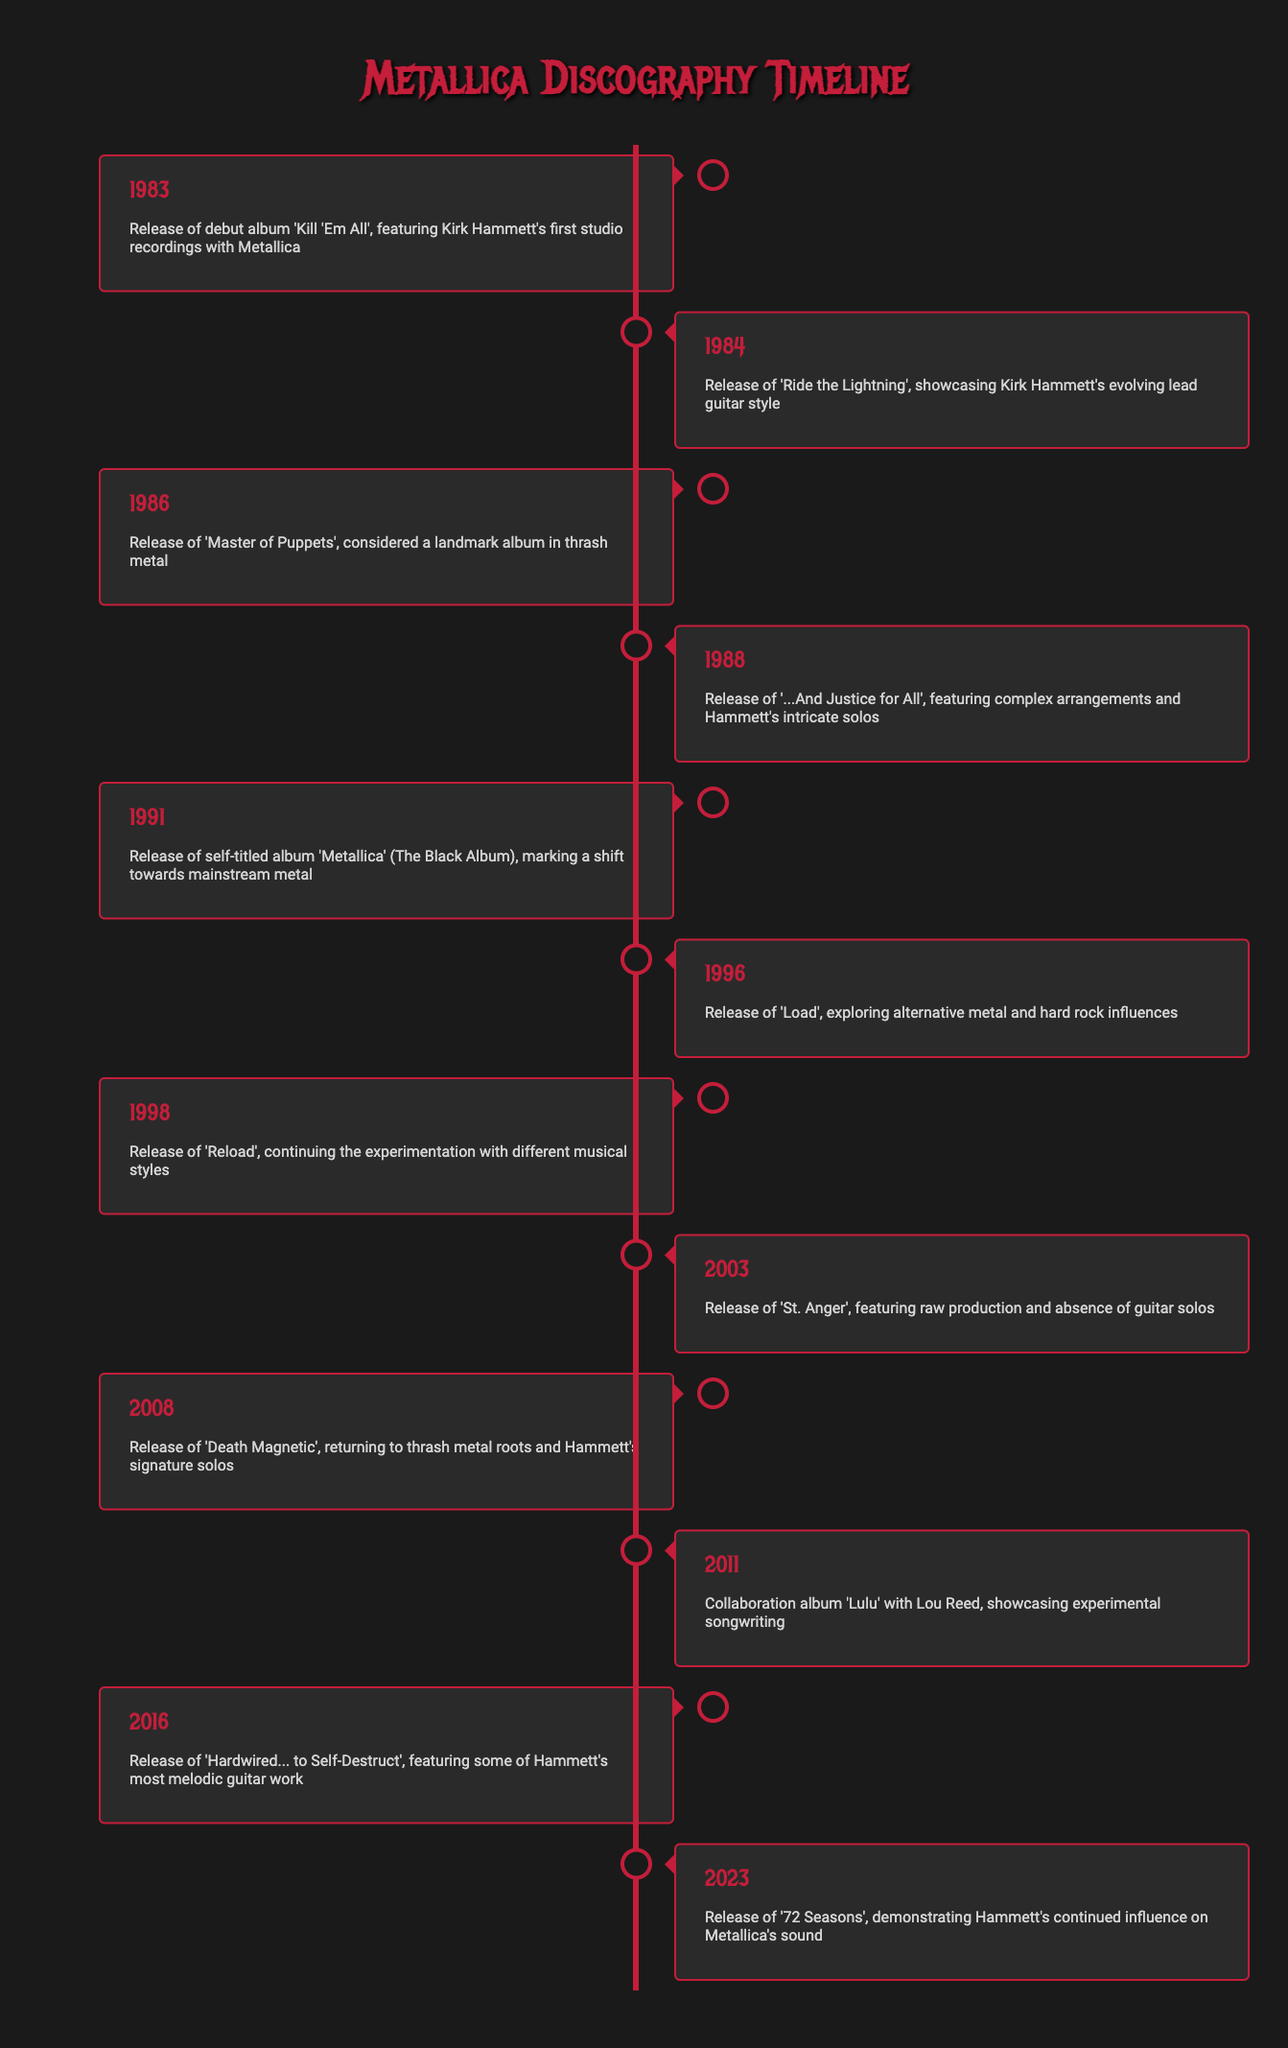What year was Metallica's debut album 'Kill 'Em All' released? The table indicates that 'Kill 'Em All' was released in 1983. This information is found in the first row of the timeline.
Answer: 1983 Which album showcased Kirk Hammett's evolving lead guitar style? According to the table, 'Ride the Lightning,' released in 1984, is noted for showcasing Kirk Hammett's evolving lead guitar style. This is in the second row of the timeline.
Answer: Ride the Lightning How many years passed between the release of 'Master of Puppets' and 'Load'? 'Master of Puppets' was released in 1986 and 'Load' in 1996. The difference is 1996 - 1986 = 10 years.
Answer: 10 years Did Metallica release an album in 2003? The table confirms that 'St. Anger' was released in 2003, indicating that an album was indeed released that year. This information is found in the ninth row.
Answer: Yes In which year did Metallica mark a shift towards mainstream metal? The self-titled album 'Metallica' (The Black Album) was released in 1991, marked as a shift towards mainstream metal. This is found in the fifth row of the timeline.
Answer: 1991 What is the most recent album listed in the timeline and what year was it released? The timeline shows that '72 Seasons' is the most recent album, released in 2023, which is detailed in the last row of the timeline.
Answer: 72 Seasons, 2023 How many albums were released between 1986 and 1996? The albums released during this period are: 'Master of Puppets' (1986), '...And Justice for All' (1988), and 'Load' (1996). This totals 3 albums: 1988-1991-1996.
Answer: 3 albums Was 'Death Magnetic' released before or after 'Load'? The timeline indicates that 'Load' was released in 1996 and 'Death Magnetic' was released in 2008. Since 2008 is after 1996, 'Death Magnetic' was released after 'Load'.
Answer: After Did any albums feature Kirk Hammett's guitar solos in the timeline? The timeline includes several albums such as 'Ride the Lightning,' 'Master of Puppets,' 'Death Magnetic,' and 'Hardwired... to Self-Destruct' that all mention Hammett's solos, indicating that at least some albums featured them.
Answer: Yes 